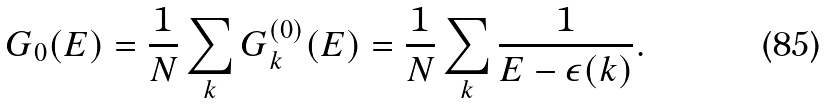<formula> <loc_0><loc_0><loc_500><loc_500>G _ { 0 } ( E ) = \frac { 1 } { N } \sum _ { k } G _ { k } ^ { ( 0 ) } ( E ) = \frac { 1 } { N } \sum _ { k } \frac { 1 } { E - \epsilon ( k ) } .</formula> 